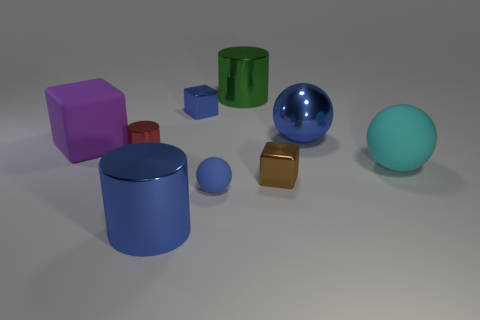Add 1 tiny green spheres. How many objects exist? 10 Subtract all spheres. How many objects are left? 6 Subtract 0 cyan blocks. How many objects are left? 9 Subtract all big green cylinders. Subtract all brown shiny objects. How many objects are left? 7 Add 3 matte things. How many matte things are left? 6 Add 8 red things. How many red things exist? 9 